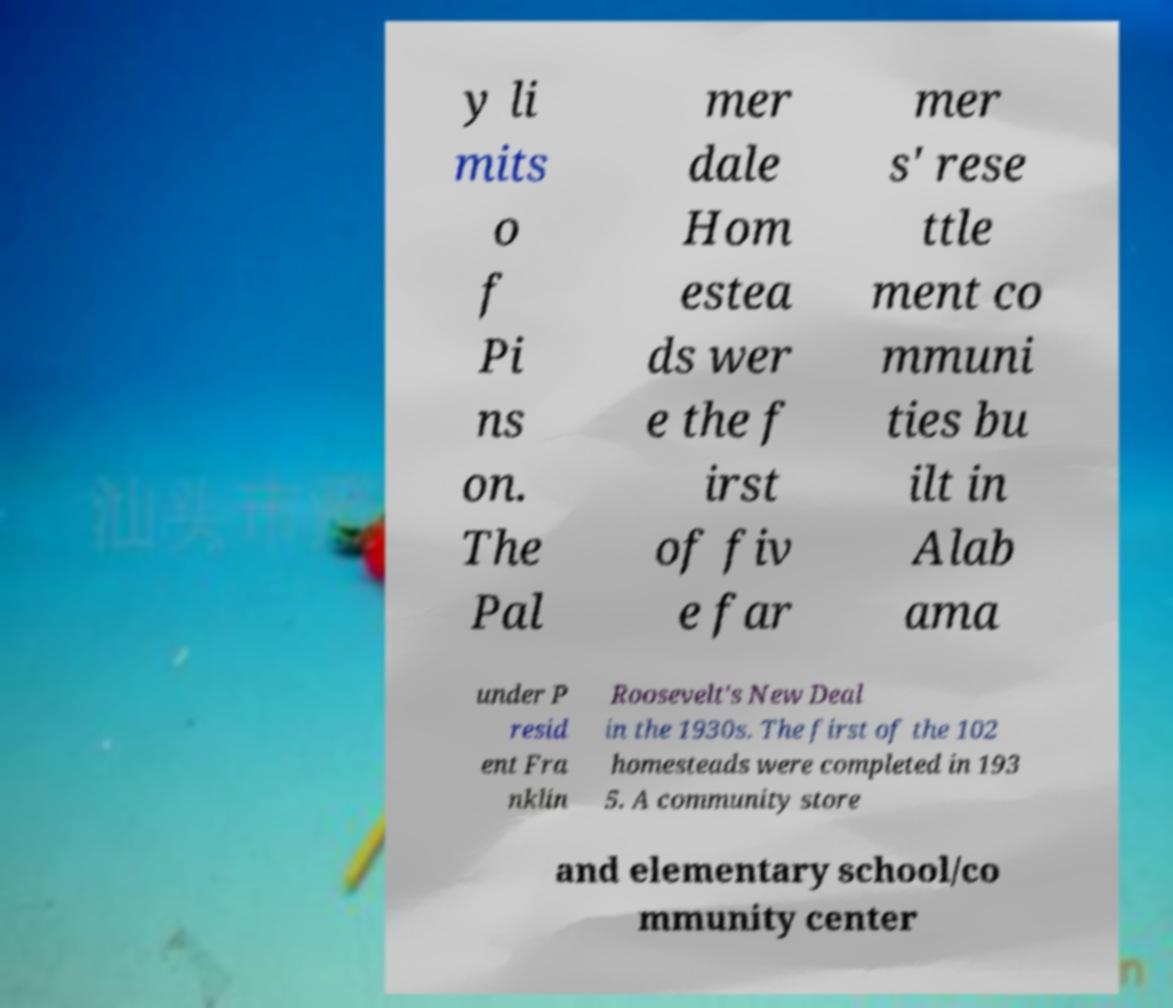Could you assist in decoding the text presented in this image and type it out clearly? y li mits o f Pi ns on. The Pal mer dale Hom estea ds wer e the f irst of fiv e far mer s' rese ttle ment co mmuni ties bu ilt in Alab ama under P resid ent Fra nklin Roosevelt's New Deal in the 1930s. The first of the 102 homesteads were completed in 193 5. A community store and elementary school/co mmunity center 